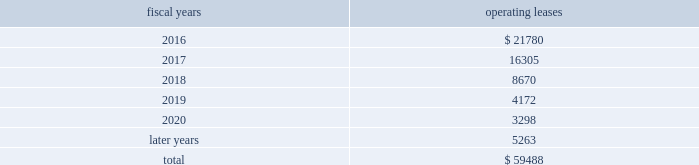Analog devices , inc .
Notes to consolidated financial statements 2014 ( continued ) the following is a schedule of future minimum rental payments required under long-term operating leases at october 31 , operating fiscal years leases .
12 .
Commitments and contingencies from time to time , in the ordinary course of the company 2019s business , various claims , charges and litigation are asserted or commenced against the company arising from , or related to , contractual matters , patents , trademarks , personal injury , environmental matters , product liability , insurance coverage and personnel and employment disputes .
As to such claims and litigation , the company can give no assurance that it will prevail .
The company does not believe that any current legal matters will have a material adverse effect on the company 2019s financial position , results of operations or cash flows .
13 .
Retirement plans the company and its subsidiaries have various savings and retirement plans covering substantially all employees .
The company maintains a defined contribution plan for the benefit of its eligible u.s .
Employees .
This plan provides for company contributions of up to 5% ( 5 % ) of each participant 2019s total eligible compensation .
In addition , the company contributes an amount equal to each participant 2019s pre-tax contribution , if any , up to a maximum of 3% ( 3 % ) of each participant 2019s total eligible compensation .
The total expense related to the defined contribution plan for u.s .
Employees was $ 26.3 million in fiscal 2015 , $ 24.1 million in fiscal 2014 and $ 23.1 million in fiscal 2013 .
The company also has various defined benefit pension and other retirement plans for certain non-u.s .
Employees that are consistent with local statutory requirements and practices .
The total expense related to the various defined benefit pension and other retirement plans for certain non-u.s .
Employees , excluding settlement charges related to the company's irish defined benefit plan , was $ 33.3 million in fiscal 2015 , $ 29.8 million in fiscal 2014 and $ 26.5 million in fiscal 2013 .
Non-u.s .
Plan disclosures during fiscal 2015 , the company converted the benefits provided to participants in the company 2019s irish defined benefits pension plan ( the db plan ) to benefits provided under the company 2019s irish defined contribution plan .
As a result , in fiscal 2015 the company recorded expenses of $ 223.7 million , including settlement charges , legal , accounting and other professional fees to settle the pension obligation .
The assets related to the db plan were liquidated and used to purchase annuities for retirees and distributed to active and deferred members' accounts in the company's irish defined contribution plan in connection with the plan conversion .
Accordingly , plan assets for the db plan were zero as of the end of fiscal 2015 .
The company 2019s funding policy for its foreign defined benefit pension plans is consistent with the local requirements of each country .
The plans 2019 assets consist primarily of u.s .
And non-u.s .
Equity securities , bonds , property and cash .
The benefit obligations and related assets under these plans have been measured at october 31 , 2015 and november 1 , 2014 .
Components of net periodic benefit cost net annual periodic pension cost of non-u.s .
Plans is presented in the following table: .
What portion of the future minimum rental payments is due after 5 years? 
Computations: (5263 / 59488)
Answer: 0.08847. 